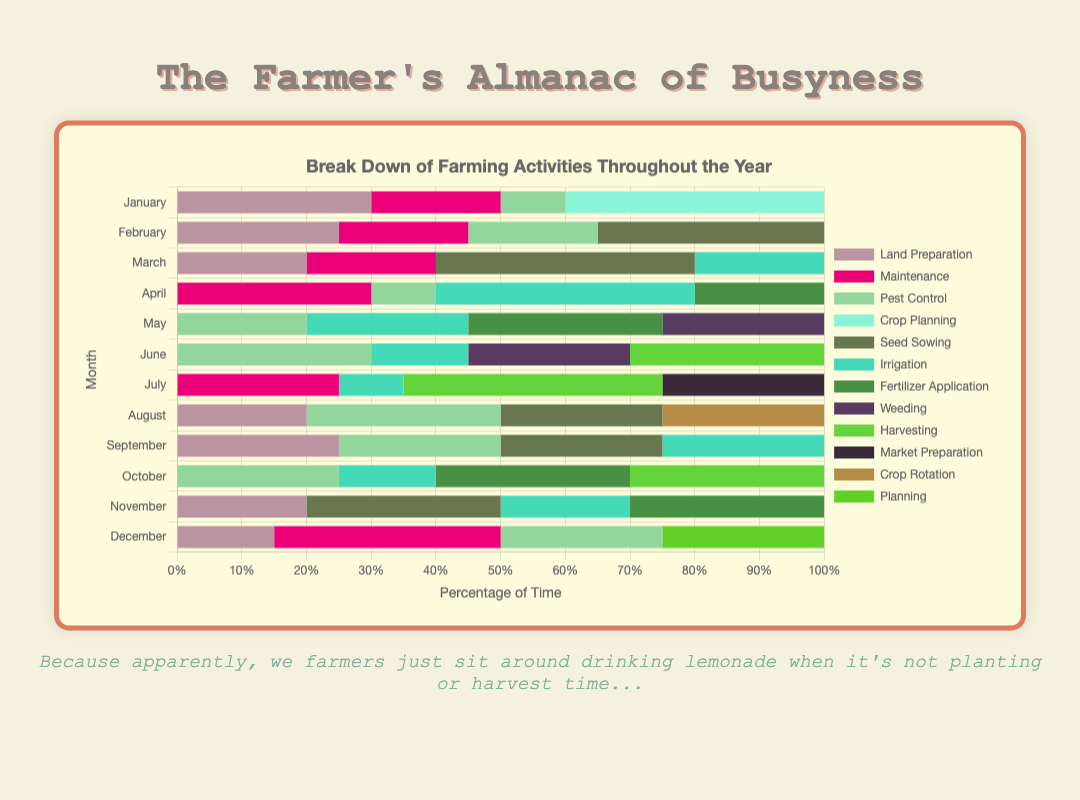Which month has the highest percentage of time spent on land preparation? By looking at the figure, you can see the horizontal stacked bars for each month. Identify the section labeled as land preparation and observe which month has the longest section.
Answer: January During which month is the least time spent on irrigation? Examine the length of the segments representing irrigation across all months. The shortest segment represents the least time spent.
Answer: July In which month does maintenance take up a higher percentage of time, January or July? Compare the lengths of the maintenance segments for January and July. Take note of which segment is longer.
Answer: July What's the combined percentage of time spent on seed sowing in March and August? Observe the lengths of the segments labeled seed sowing for both March and August, then sum their percentages. March has 40% and August has 25%, so 40% + 25% = 65%.
Answer: 65% Compare the time dedicated to pest control in May and September. Which month has a higher percentage? Look at the segments representing pest control in May and September. The longer segment corresponds to a higher percentage.
Answer: September Which activity is carried out in every month except December? Scan across the activities for each month listed. Notice which activity is consistently present except in December's stacked bar.
Answer: Irrigation What is the sum percentage of all activities in April? Sum the percentages of all activities in April. These are irrigation (40%), maintenance (30%), fertilizer application (20%), and pest control (10%). Therefore, the total is 40% + 30% + 20% + 10% = 100%.
Answer: 100% What’s the difference in time spent on maintenance between January and December? Calculate the percentage difference by looking at the maintenance segments for January and December. January has 20% and December has 35%. The difference is 35% - 20% = 15%.
Answer: 15% How does the length of the crop planning segment in January compare to the planning segment in December? Locate the segments labeled crop planning in January and planning in December, compare their lengths to see which is longer.
Answer: January 